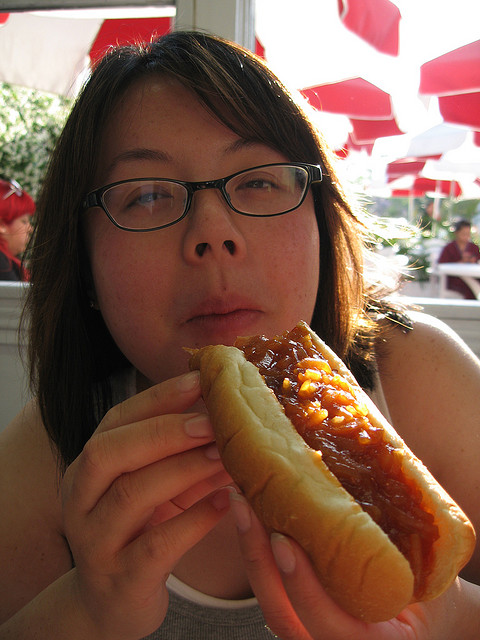Can you describe the setting where the person is seated? The person appears to be seated in a casual dining area, likely a fast-food or outdoor eating space with white tables and red sun umbrellas visible in the background, indicating a sunny day. 